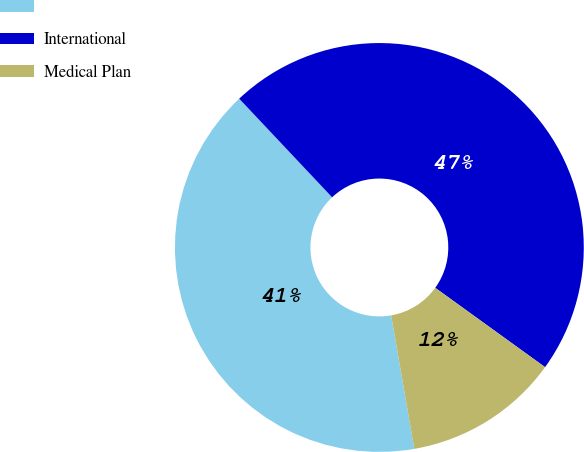Convert chart. <chart><loc_0><loc_0><loc_500><loc_500><pie_chart><ecel><fcel>International<fcel>Medical Plan<nl><fcel>40.71%<fcel>46.98%<fcel>12.31%<nl></chart> 